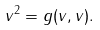Convert formula to latex. <formula><loc_0><loc_0><loc_500><loc_500>v ^ { 2 } = g ( v , v ) .</formula> 